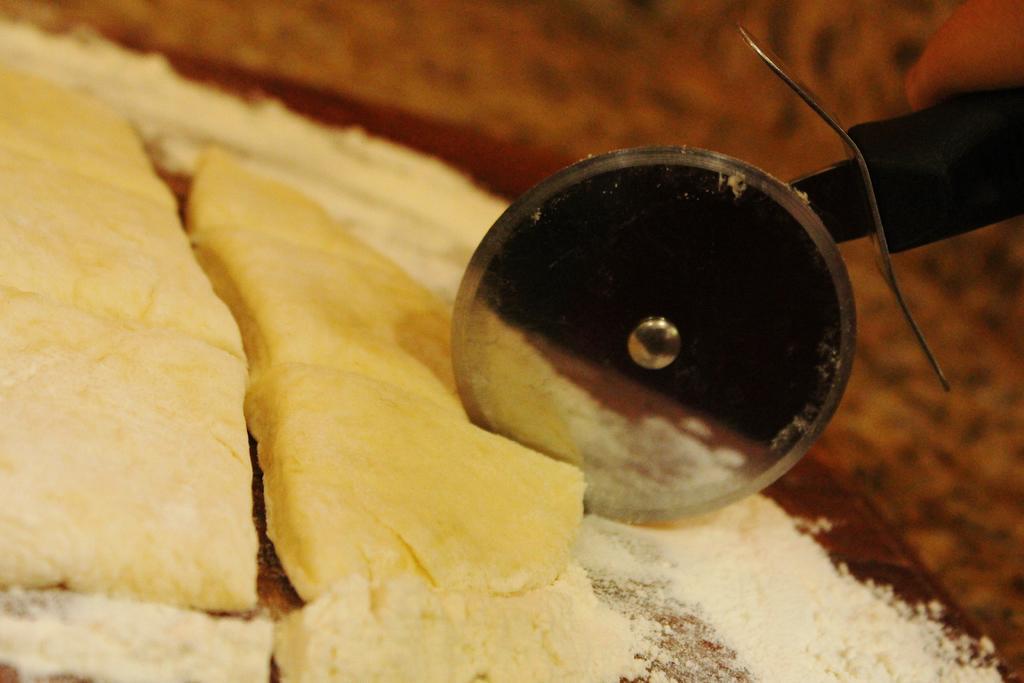Describe this image in one or two sentences. In this picture I can observe pizza cutter. There is some food placed on the table. This food is in yellow color. The background is blurred. 